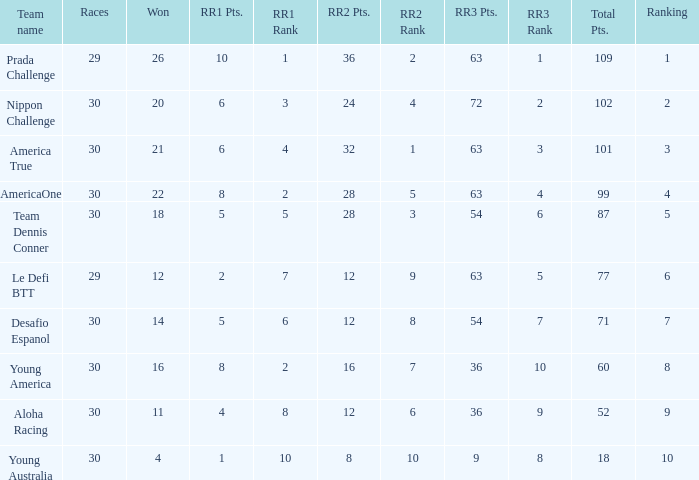Name the min total pts for team dennis conner 87.0. 